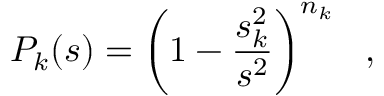Convert formula to latex. <formula><loc_0><loc_0><loc_500><loc_500>P _ { k } ( s ) = \left ( 1 - { \frac { s _ { k } ^ { 2 } } { s ^ { 2 } } } \right ) ^ { n _ { k } } \ \ ,</formula> 